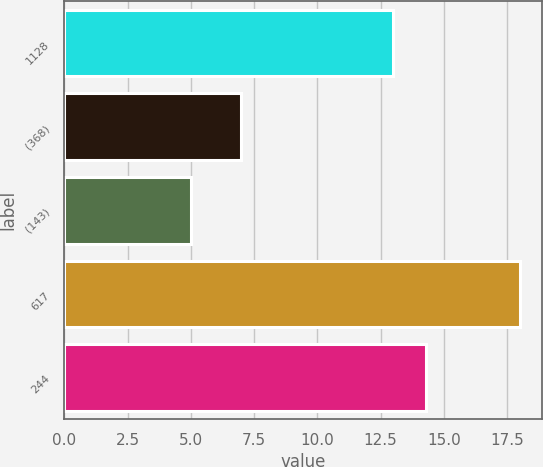<chart> <loc_0><loc_0><loc_500><loc_500><bar_chart><fcel>1128<fcel>(368)<fcel>(143)<fcel>617<fcel>244<nl><fcel>13<fcel>7<fcel>5<fcel>18<fcel>14.3<nl></chart> 